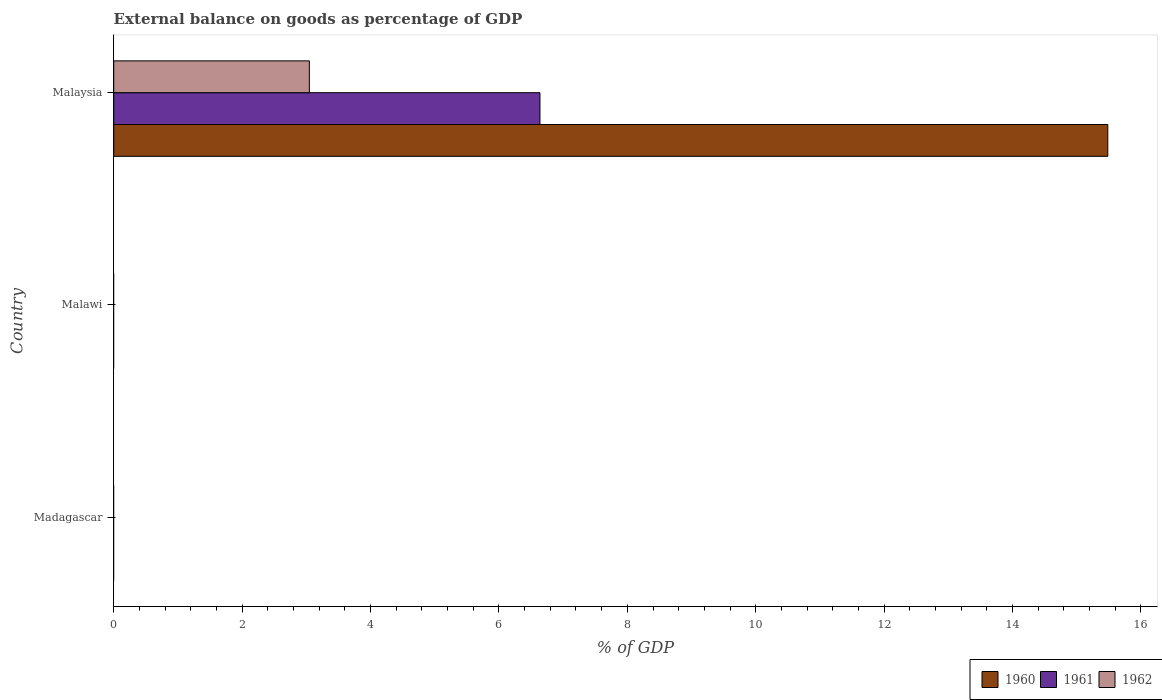Are the number of bars on each tick of the Y-axis equal?
Your response must be concise. No. How many bars are there on the 2nd tick from the top?
Provide a short and direct response. 0. How many bars are there on the 3rd tick from the bottom?
Make the answer very short. 3. What is the label of the 1st group of bars from the top?
Your response must be concise. Malaysia. In how many cases, is the number of bars for a given country not equal to the number of legend labels?
Your response must be concise. 2. What is the external balance on goods as percentage of GDP in 1960 in Malawi?
Make the answer very short. 0. Across all countries, what is the maximum external balance on goods as percentage of GDP in 1961?
Give a very brief answer. 6.64. In which country was the external balance on goods as percentage of GDP in 1961 maximum?
Your answer should be very brief. Malaysia. What is the total external balance on goods as percentage of GDP in 1962 in the graph?
Offer a terse response. 3.05. What is the difference between the external balance on goods as percentage of GDP in 1961 in Malawi and the external balance on goods as percentage of GDP in 1960 in Madagascar?
Make the answer very short. 0. What is the average external balance on goods as percentage of GDP in 1961 per country?
Keep it short and to the point. 2.21. What is the difference between the external balance on goods as percentage of GDP in 1961 and external balance on goods as percentage of GDP in 1960 in Malaysia?
Offer a terse response. -8.85. In how many countries, is the external balance on goods as percentage of GDP in 1960 greater than 9.2 %?
Your answer should be very brief. 1. What is the difference between the highest and the lowest external balance on goods as percentage of GDP in 1961?
Provide a short and direct response. 6.64. In how many countries, is the external balance on goods as percentage of GDP in 1960 greater than the average external balance on goods as percentage of GDP in 1960 taken over all countries?
Your answer should be compact. 1. Is it the case that in every country, the sum of the external balance on goods as percentage of GDP in 1961 and external balance on goods as percentage of GDP in 1962 is greater than the external balance on goods as percentage of GDP in 1960?
Provide a succinct answer. No. How many bars are there?
Offer a terse response. 3. What is the difference between two consecutive major ticks on the X-axis?
Your response must be concise. 2. How are the legend labels stacked?
Make the answer very short. Horizontal. What is the title of the graph?
Provide a short and direct response. External balance on goods as percentage of GDP. What is the label or title of the X-axis?
Make the answer very short. % of GDP. What is the label or title of the Y-axis?
Your answer should be very brief. Country. What is the % of GDP of 1960 in Madagascar?
Make the answer very short. 0. What is the % of GDP in 1961 in Madagascar?
Keep it short and to the point. 0. What is the % of GDP in 1962 in Madagascar?
Give a very brief answer. 0. What is the % of GDP of 1961 in Malawi?
Provide a short and direct response. 0. What is the % of GDP of 1962 in Malawi?
Your answer should be compact. 0. What is the % of GDP in 1960 in Malaysia?
Keep it short and to the point. 15.48. What is the % of GDP of 1961 in Malaysia?
Make the answer very short. 6.64. What is the % of GDP of 1962 in Malaysia?
Your answer should be very brief. 3.05. Across all countries, what is the maximum % of GDP in 1960?
Your answer should be compact. 15.48. Across all countries, what is the maximum % of GDP in 1961?
Provide a short and direct response. 6.64. Across all countries, what is the maximum % of GDP of 1962?
Offer a terse response. 3.05. Across all countries, what is the minimum % of GDP in 1960?
Your response must be concise. 0. What is the total % of GDP in 1960 in the graph?
Offer a very short reply. 15.48. What is the total % of GDP of 1961 in the graph?
Give a very brief answer. 6.64. What is the total % of GDP in 1962 in the graph?
Your response must be concise. 3.05. What is the average % of GDP of 1960 per country?
Keep it short and to the point. 5.16. What is the average % of GDP in 1961 per country?
Offer a very short reply. 2.21. What is the average % of GDP in 1962 per country?
Offer a very short reply. 1.02. What is the difference between the % of GDP in 1960 and % of GDP in 1961 in Malaysia?
Provide a short and direct response. 8.85. What is the difference between the % of GDP of 1960 and % of GDP of 1962 in Malaysia?
Provide a short and direct response. 12.44. What is the difference between the % of GDP in 1961 and % of GDP in 1962 in Malaysia?
Your response must be concise. 3.59. What is the difference between the highest and the lowest % of GDP of 1960?
Your answer should be compact. 15.48. What is the difference between the highest and the lowest % of GDP in 1961?
Your answer should be compact. 6.64. What is the difference between the highest and the lowest % of GDP in 1962?
Offer a very short reply. 3.05. 